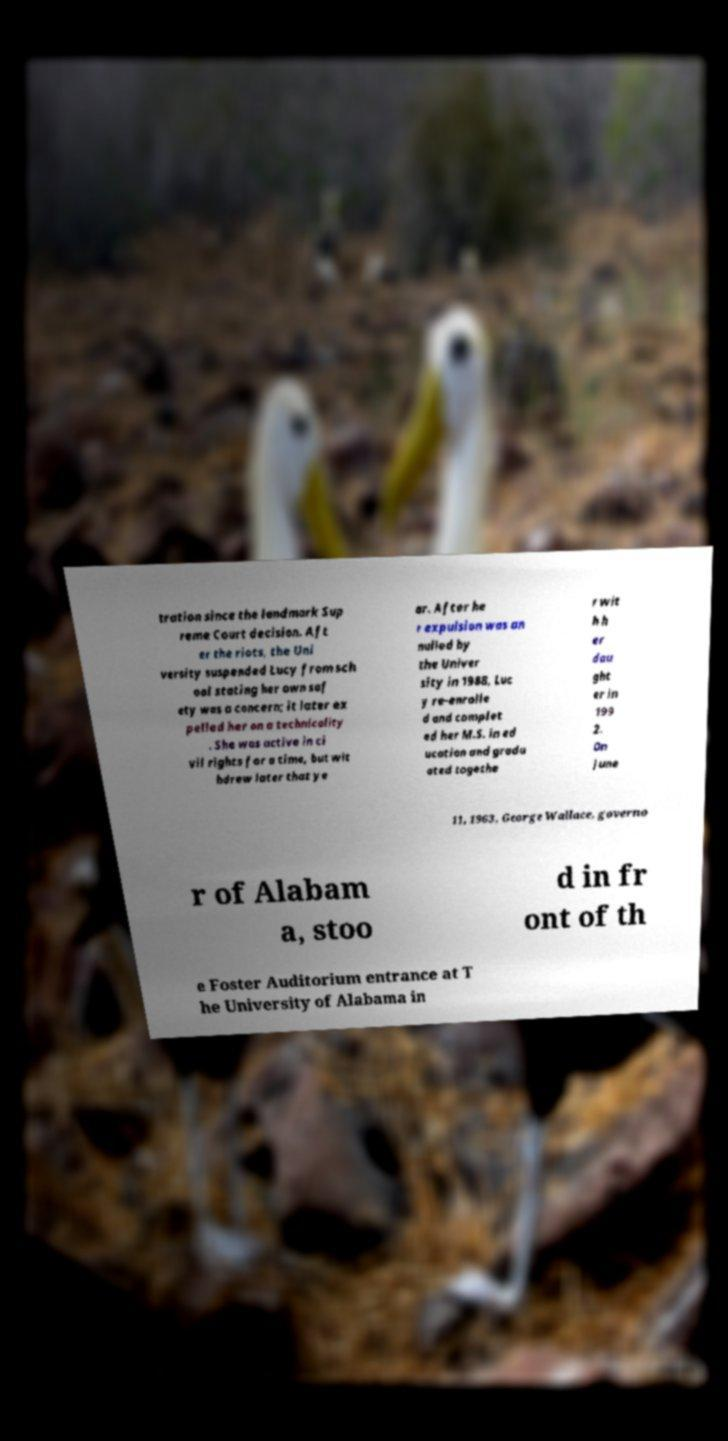For documentation purposes, I need the text within this image transcribed. Could you provide that? tration since the landmark Sup reme Court decision. Aft er the riots, the Uni versity suspended Lucy from sch ool stating her own saf ety was a concern; it later ex pelled her on a technicality . She was active in ci vil rights for a time, but wit hdrew later that ye ar. After he r expulsion was an nulled by the Univer sity in 1988, Luc y re-enrolle d and complet ed her M.S. in ed ucation and gradu ated togethe r wit h h er dau ght er in 199 2. On June 11, 1963, George Wallace, governo r of Alabam a, stoo d in fr ont of th e Foster Auditorium entrance at T he University of Alabama in 